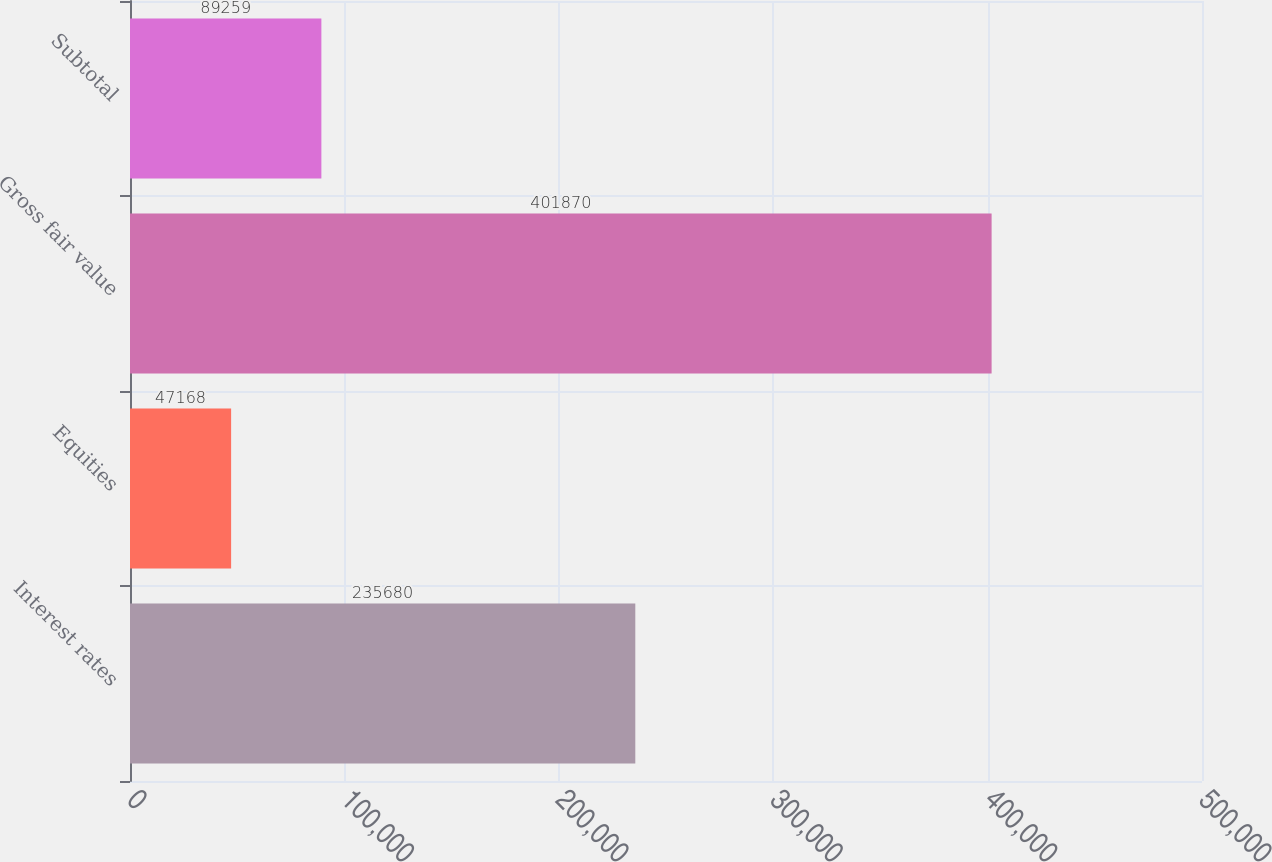Convert chart to OTSL. <chart><loc_0><loc_0><loc_500><loc_500><bar_chart><fcel>Interest rates<fcel>Equities<fcel>Gross fair value<fcel>Subtotal<nl><fcel>235680<fcel>47168<fcel>401870<fcel>89259<nl></chart> 